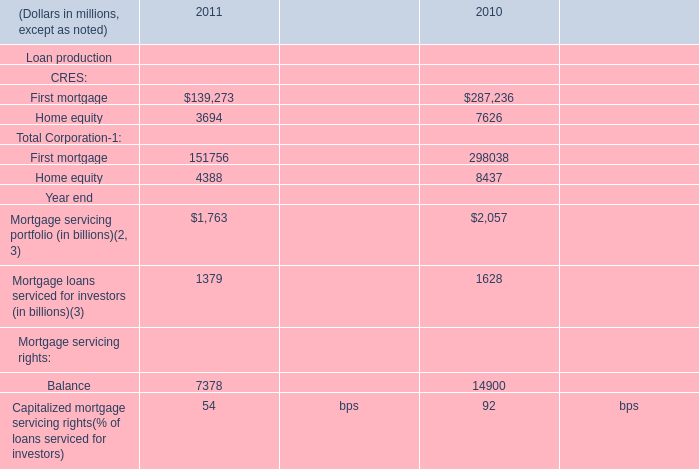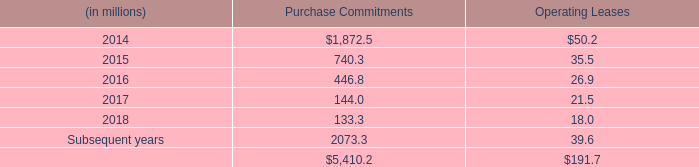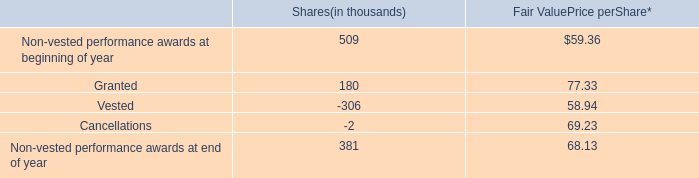what is the total value of non-vested performance awards at end of year , ( in millions ) ? 
Computations: ((381 - 68.13) / 1000)
Answer: 0.31287. 